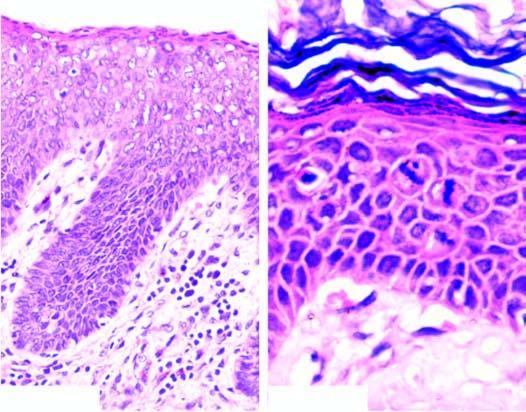does the central area show mitotic figures in the layers of squamous epithelium?
Answer the question using a single word or phrase. No 